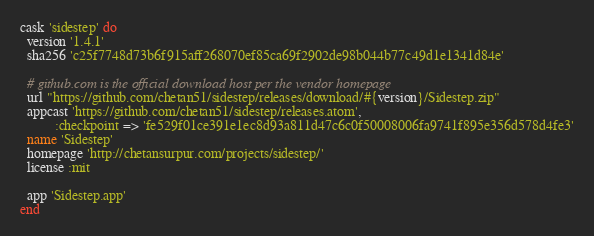Convert code to text. <code><loc_0><loc_0><loc_500><loc_500><_Ruby_>cask 'sidestep' do
  version '1.4.1'
  sha256 'c25f7748d73b6f915aff268070ef85ca69f2902de98b044b77c49d1e1341d84e'

  # github.com is the official download host per the vendor homepage
  url "https://github.com/chetan51/sidestep/releases/download/#{version}/Sidestep.zip"
  appcast 'https://github.com/chetan51/sidestep/releases.atom',
          :checkpoint => 'fe529f01ce391e1ec8d93a811d47c6c0f50008006fa9741f895e356d578d4fe3'
  name 'Sidestep'
  homepage 'http://chetansurpur.com/projects/sidestep/'
  license :mit

  app 'Sidestep.app'
end
</code> 